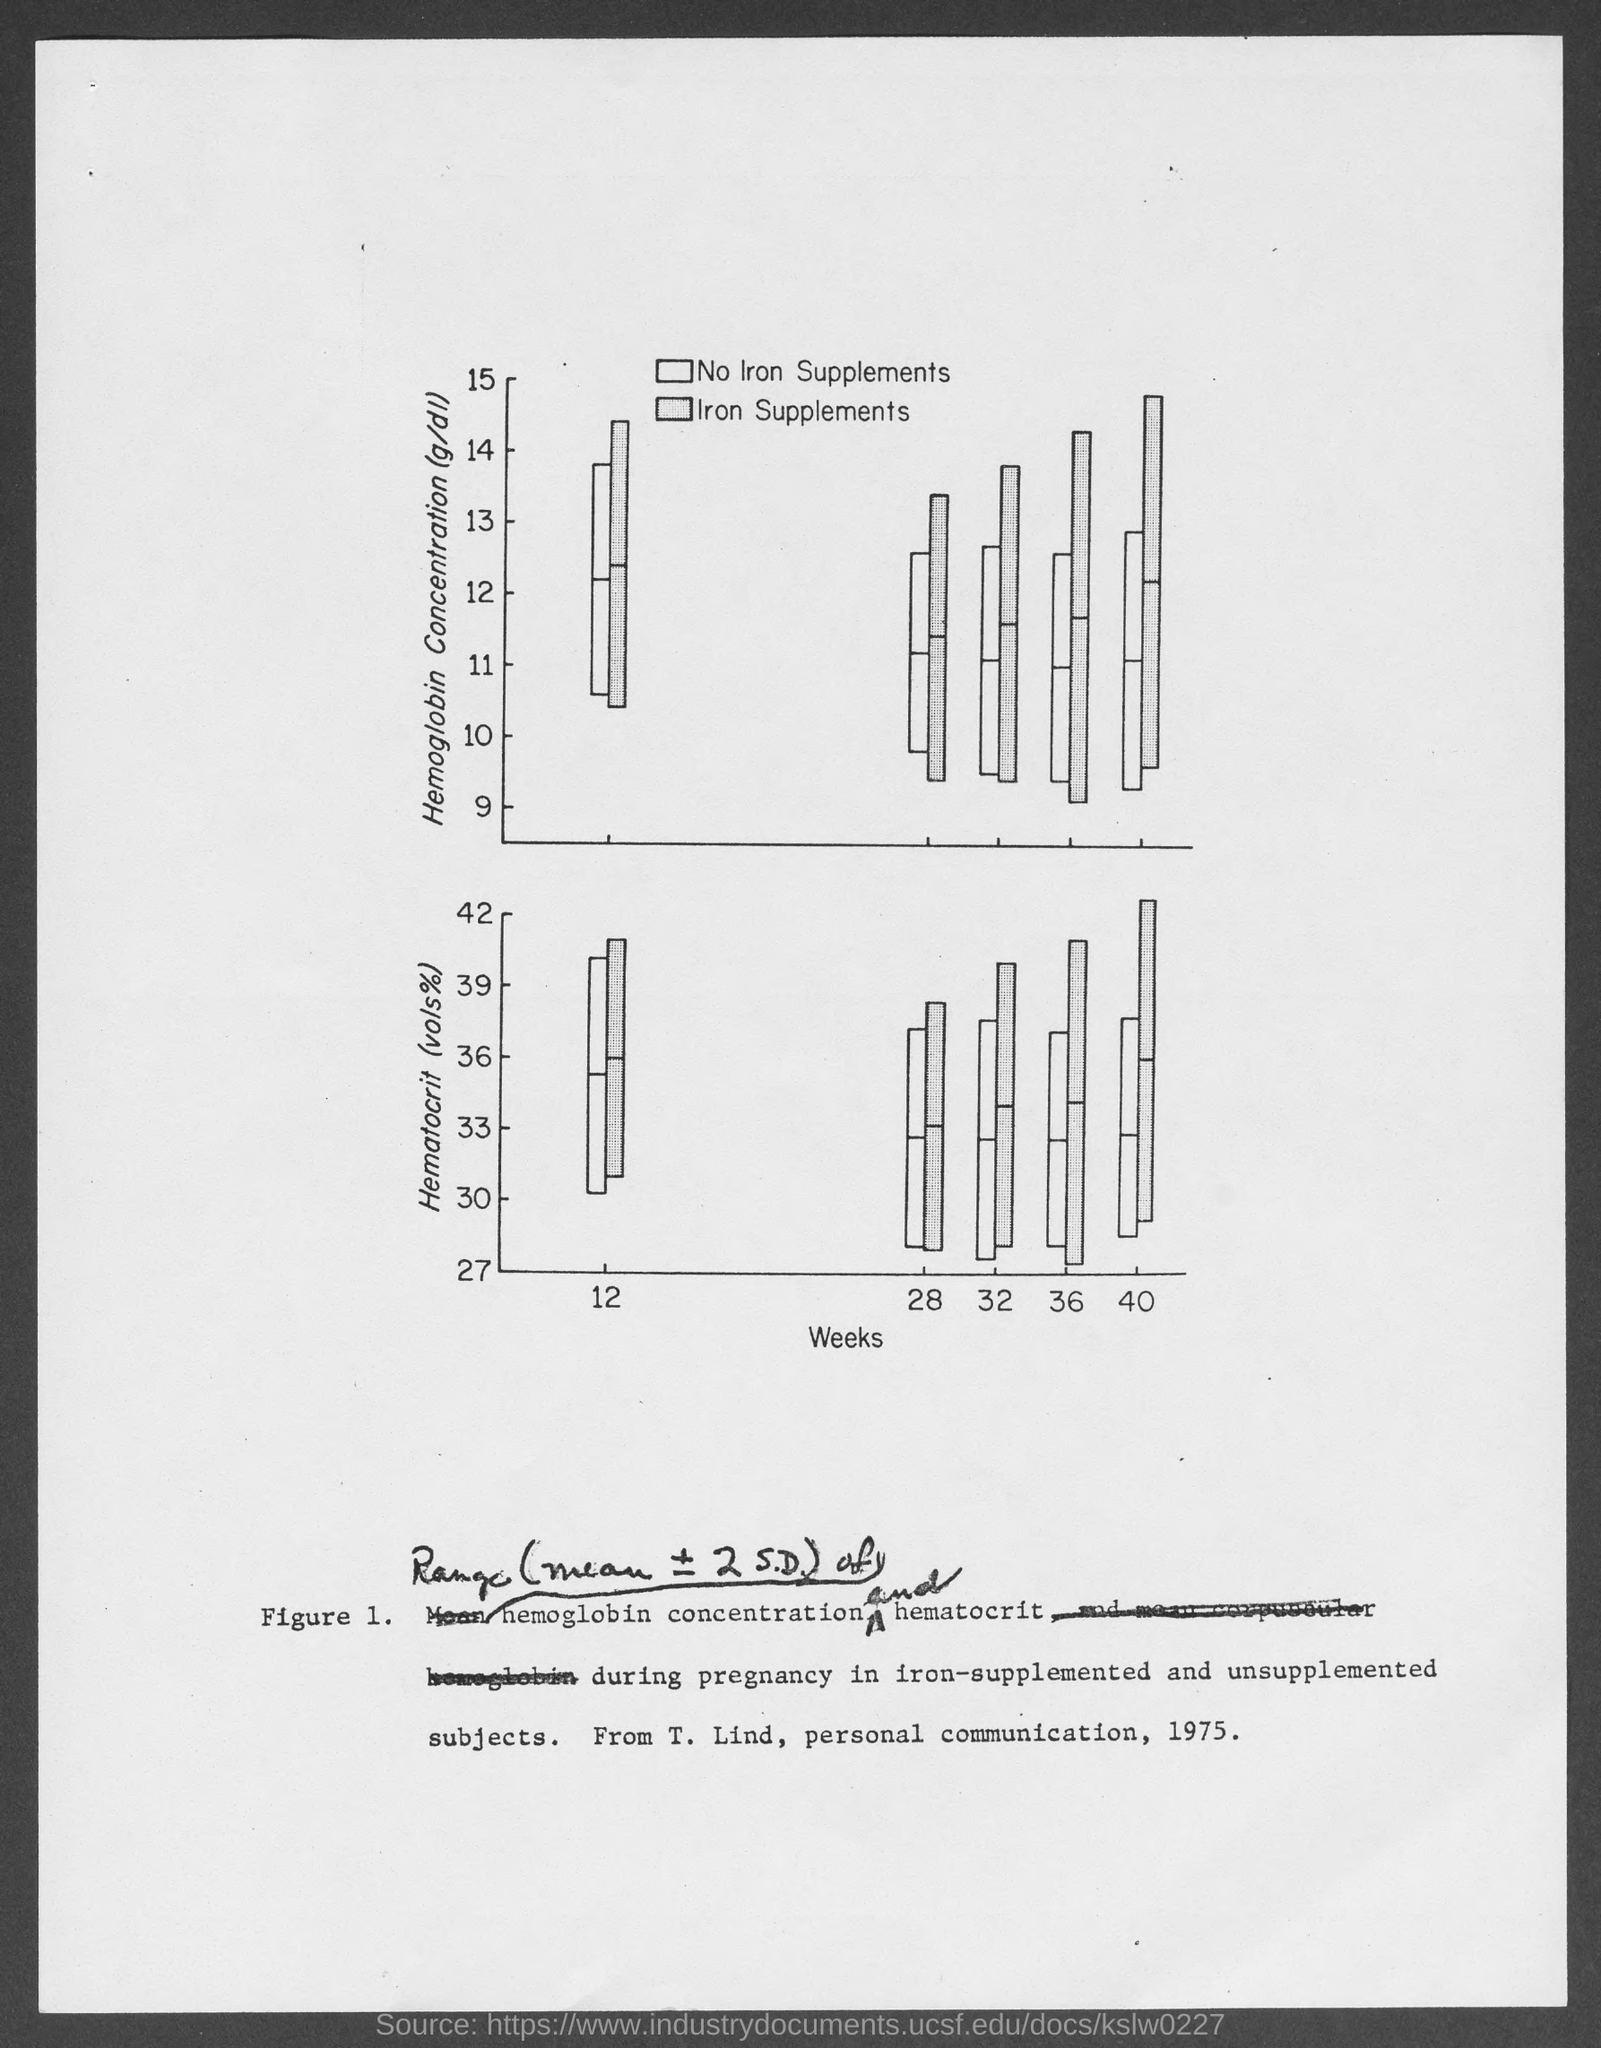What is the figure no.?
Your answer should be compact. Figure 1. 